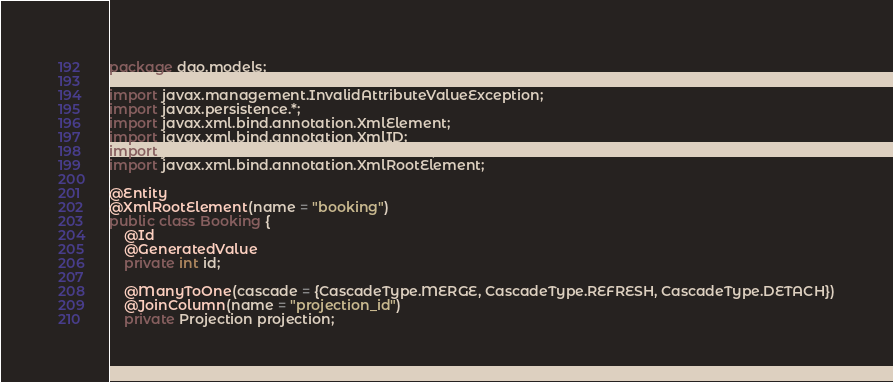<code> <loc_0><loc_0><loc_500><loc_500><_Java_>package dao.models;

import javax.management.InvalidAttributeValueException;
import javax.persistence.*;
import javax.xml.bind.annotation.XmlElement;
import javax.xml.bind.annotation.XmlID;
import javax.xml.bind.annotation.XmlIDREF;
import javax.xml.bind.annotation.XmlRootElement;

@Entity
@XmlRootElement(name = "booking")
public class Booking {
    @Id
    @GeneratedValue
    private int id;

    @ManyToOne(cascade = {CascadeType.MERGE, CascadeType.REFRESH, CascadeType.DETACH})
    @JoinColumn(name = "projection_id")
    private Projection projection;
</code> 